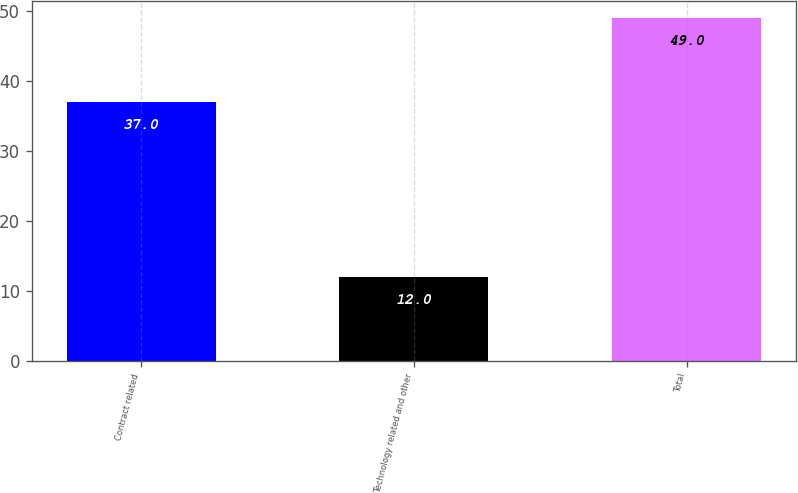Convert chart to OTSL. <chart><loc_0><loc_0><loc_500><loc_500><bar_chart><fcel>Contract related<fcel>Technology related and other<fcel>Total<nl><fcel>37<fcel>12<fcel>49<nl></chart> 